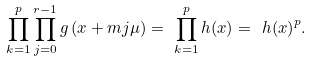<formula> <loc_0><loc_0><loc_500><loc_500>\prod ^ { p } _ { k = 1 } { \prod ^ { r - 1 } _ { j = 0 } { g \left ( x + m j \mu \right ) } } = \ \prod ^ { p } _ { k = 1 } { h ( x ) } = \ h { \left ( x \right ) } ^ { p } .</formula> 